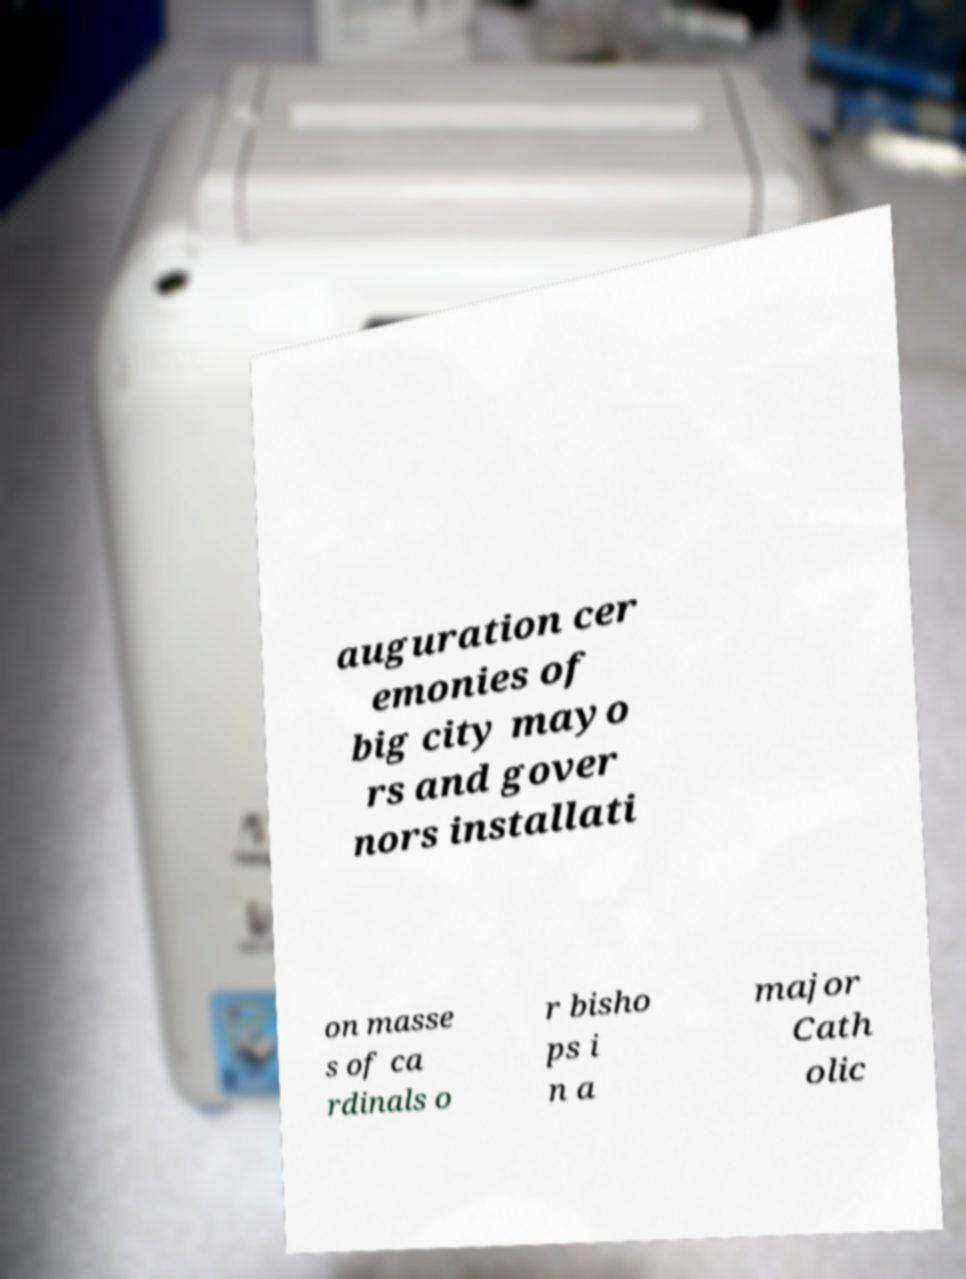Could you extract and type out the text from this image? auguration cer emonies of big city mayo rs and gover nors installati on masse s of ca rdinals o r bisho ps i n a major Cath olic 